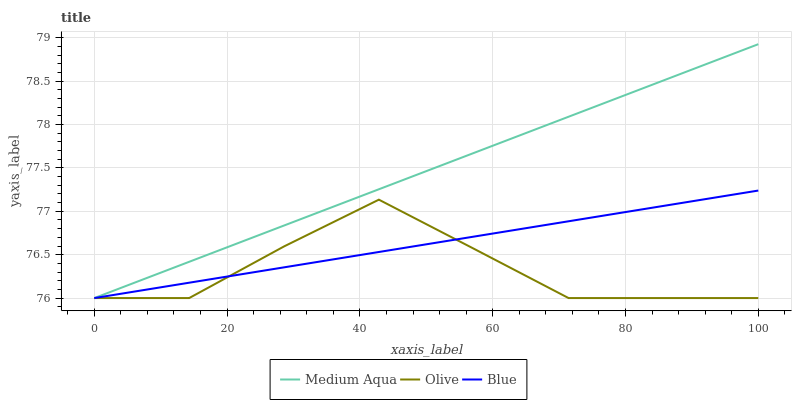Does Olive have the minimum area under the curve?
Answer yes or no. Yes. Does Medium Aqua have the maximum area under the curve?
Answer yes or no. Yes. Does Blue have the minimum area under the curve?
Answer yes or no. No. Does Blue have the maximum area under the curve?
Answer yes or no. No. Is Blue the smoothest?
Answer yes or no. Yes. Is Olive the roughest?
Answer yes or no. Yes. Is Medium Aqua the smoothest?
Answer yes or no. No. Is Medium Aqua the roughest?
Answer yes or no. No. Does Olive have the lowest value?
Answer yes or no. Yes. Does Medium Aqua have the highest value?
Answer yes or no. Yes. Does Blue have the highest value?
Answer yes or no. No. Does Medium Aqua intersect Olive?
Answer yes or no. Yes. Is Medium Aqua less than Olive?
Answer yes or no. No. Is Medium Aqua greater than Olive?
Answer yes or no. No. 